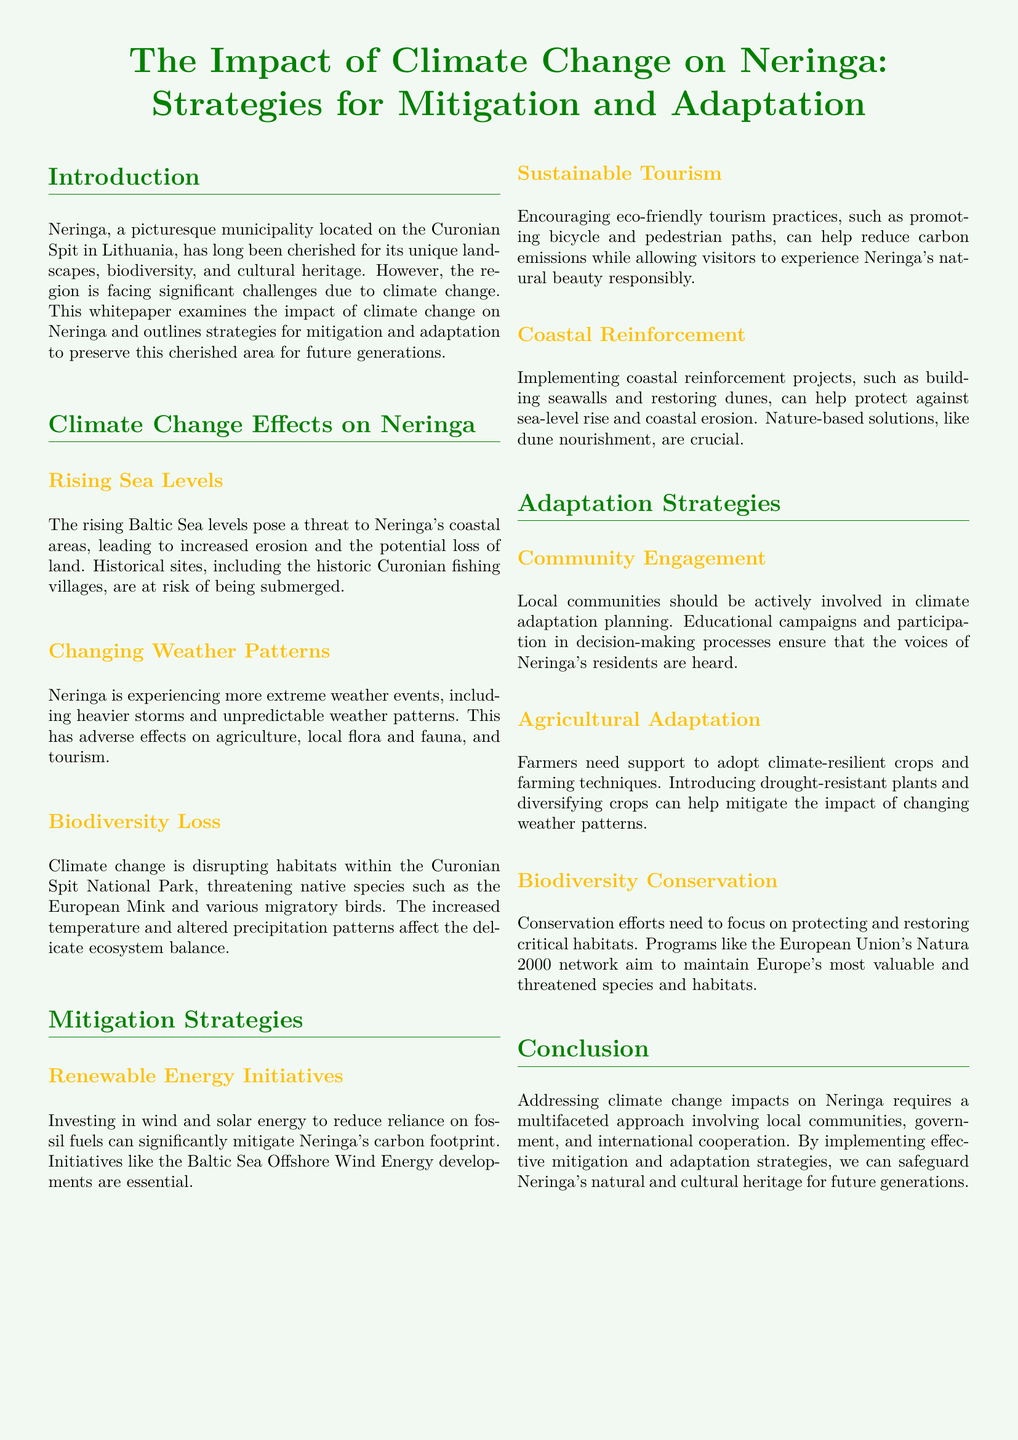What is the main location discussed in the document? The document focuses on Neringa, a municipality located on the Curonian Spit in Lithuania.
Answer: Neringa What is one significant effect of climate change mentioned? The document lists several effects, one being the threat of rising sea levels leading to increased erosion.
Answer: Rising sea levels Which specific local species is mentioned as being threatened? The document mentions native species such as the European Mink being threatened due to climate change.
Answer: European Mink What renewable energy initiatives are suggested for Neringa? The strategies include investments in wind and solar energy to reduce carbon footprint.
Answer: Wind and solar energy What type of tourism is encouraged in the document? The whitepaper advocates for sustainable tourism practices that reduce carbon emissions.
Answer: Eco-friendly tourism How should local communities engage in climate adaptation planning? The document suggests that they should be actively involved and participate in decision-making processes.
Answer: Actively involved What conservation network is mentioned in the document? The European Union's Natura 2000 network is noted for its goal of maintaining valuable and threatened species and habitats.
Answer: Natura 2000 What type of farming support is mentioned for adaptation? The document indicates that farmers need support to adopt climate-resilient crops and farming techniques.
Answer: Climate-resilient crops Which environmental challenge affects agriculture in Neringa? The document states that changing weather patterns adversely affect agriculture.
Answer: Changing weather patterns 